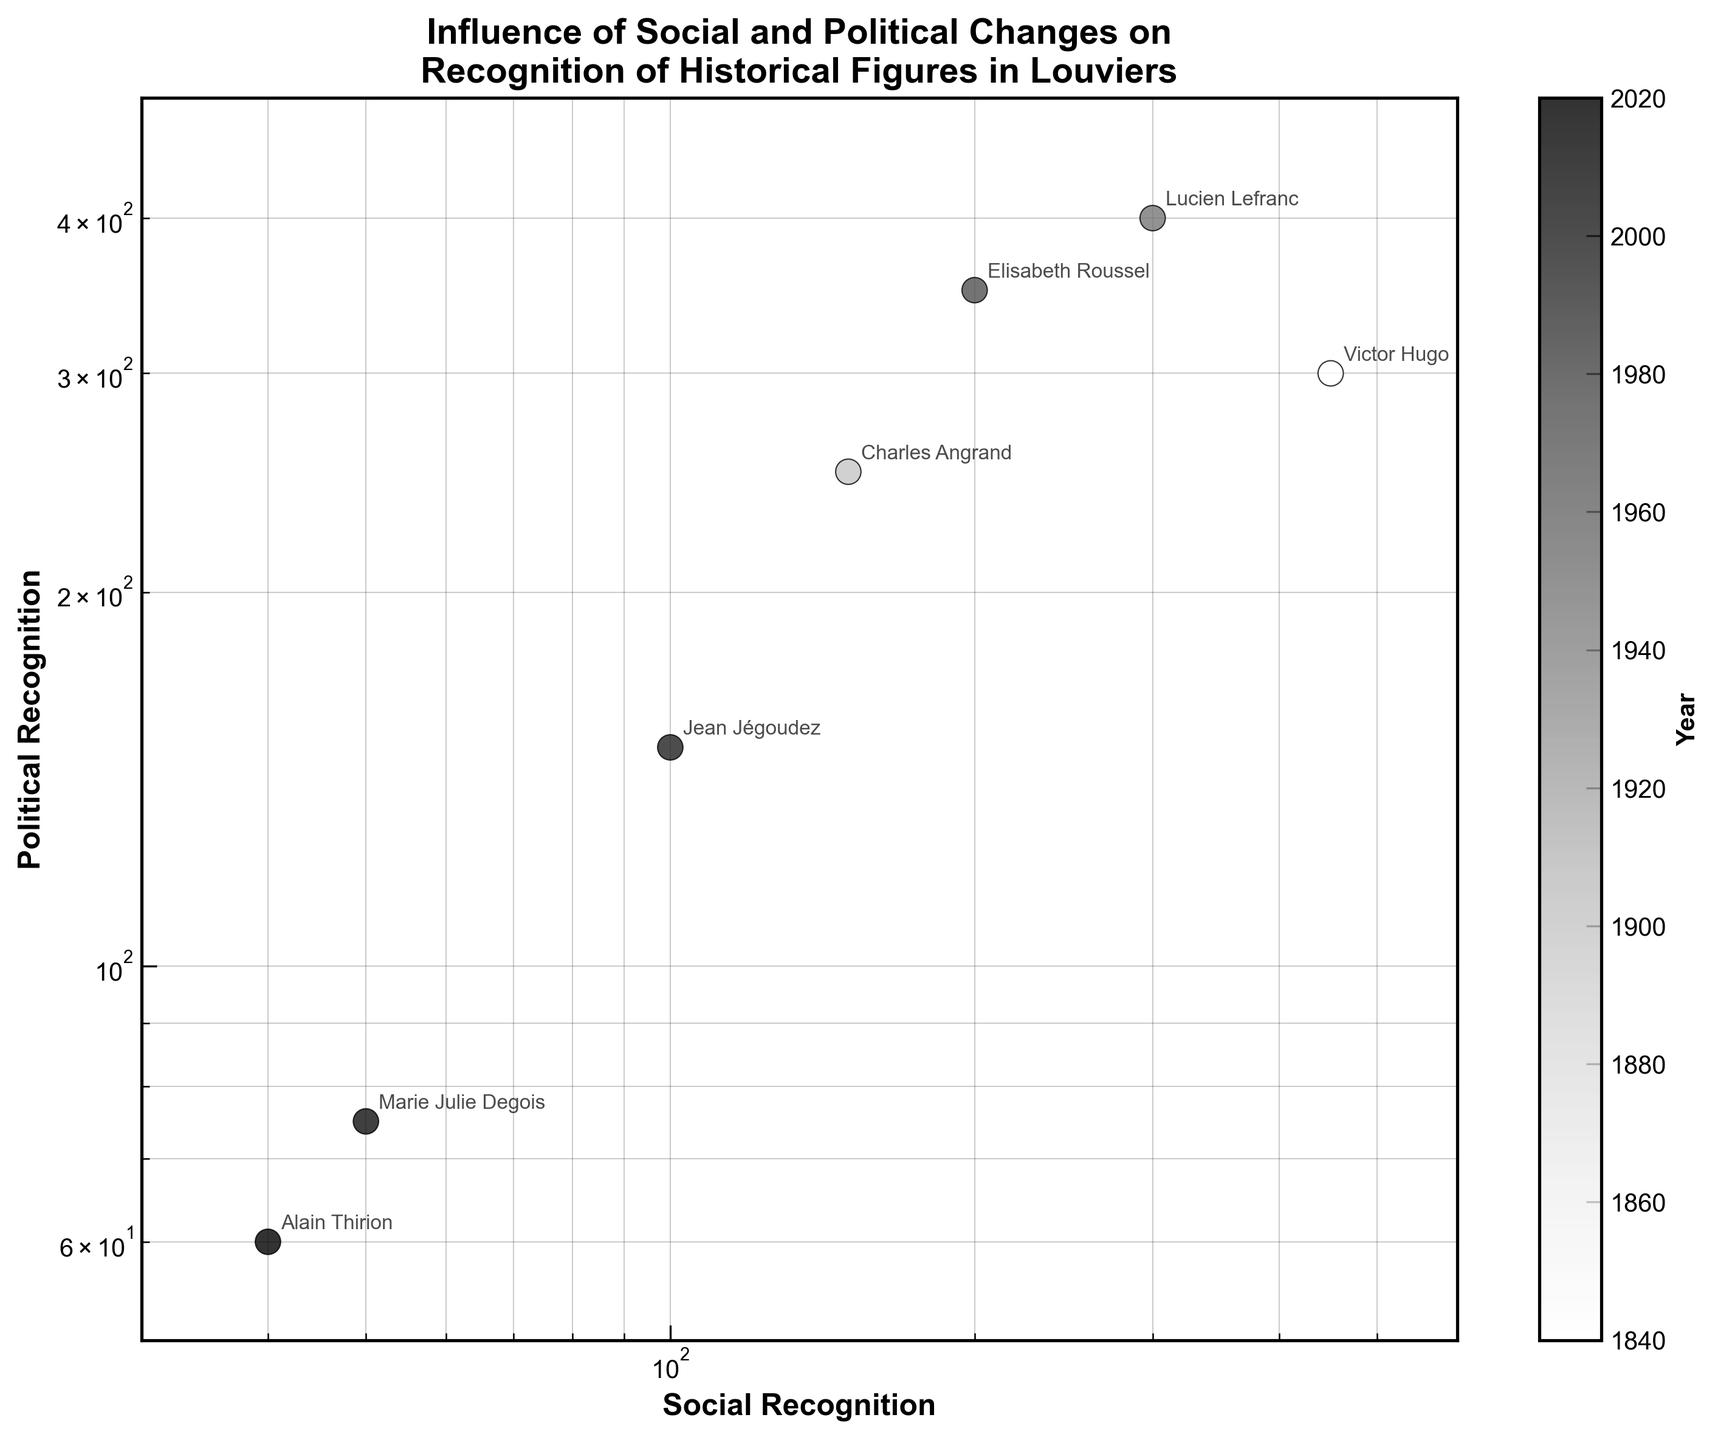What is the title of the scatter plot? The title is typically located at the top of the plot and often provides a summary of the plot's subject. In this case, the title refers to the influence of social and political changes on the recognition of historical figures in Louviers.
Answer: Influence of Social and Political Changes on Recognition of Historical Figures in Louviers How many data points are plotted in the scatter plot? Each historical figure listed in the data corresponds to a single point on the scatter plot. Counting the number of names gives the total number of data points: there are 7 names.
Answer: 7 Which figure has the highest social recognition in the dataset? By looking at the x-axis (which represents social recognition), the point furthest to the right represents the highest social recognition. Victor Hugo has the highest social recognition with 450.
Answer: Victor Hugo Compare the political recognition of Charles Angrand and Lucien Lefranc. Who has a higher value? By finding the points for Charles Angrand and Lucien Lefranc, we compare their political recognition values. Charles Angrand has 250, while Lucien Lefranc has 400, so Lucien Lefranc has a higher political recognition.
Answer: Lucien Lefranc What is the approximate range of social recognition values in the dataset? Observing the x-axis range, which is log-scaled from around 30 to 600, the smallest social recognition value is 40 (Alain Thirion) and the highest is 450 (Victor Hugo).
Answer: 40 to 450 Who has the lowest political recognition, and what is its value? By examining the y-axis (political recognition) in the scatter plot, we find the lowest point on this axis. Marie Julie Degois has the lowest political recognition value, which is 75.
Answer: Marie Julie Degois with 75 Which year corresponds to the data point with roughly equal social and political recognition? Looking for points near the line where social recognition equals political recognition, Lucien Lefranc (300, 400) and Elisabeth Roussel (200, 350) are not equal. Jean Jégoudez is near equal with values (100, 150) in the year 2000.
Answer: 2000 If a trend line was added, how might the recognition values shift over time? Observing the scatter plot's general direction over years (color-coded), both social and political recognition seems progressively decreasing as we move to recent years (darker). This suggests recognition values tend to decline over time.
Answer: Recognition values tend to decline over time How does the recognition of Elisabeth Roussel compare to that of Jean Jégoudez in terms of social and political recognition? Comparing the positions on both axes for Elisabeth Roussel and Jean Jégoudez, Elisabeth Roussel has higher values in both social (200 vs. 100) and political (350 vs. 150).
Answer: Elisabeth Roussel has higher recognition in both dimensions What might be inferred about the relationship between social and political recognition based on the scatter plot's log scale axes? If the points cluster along a discernible trend line, it suggests a correlation between social and political recognition. The log scale can help visualize multiplicative relationships. Here, the overlapping points suggest that higher social recognition may generally align with higher political recognition.
Answer: There seems to be a positive correlation between social and political recognition 